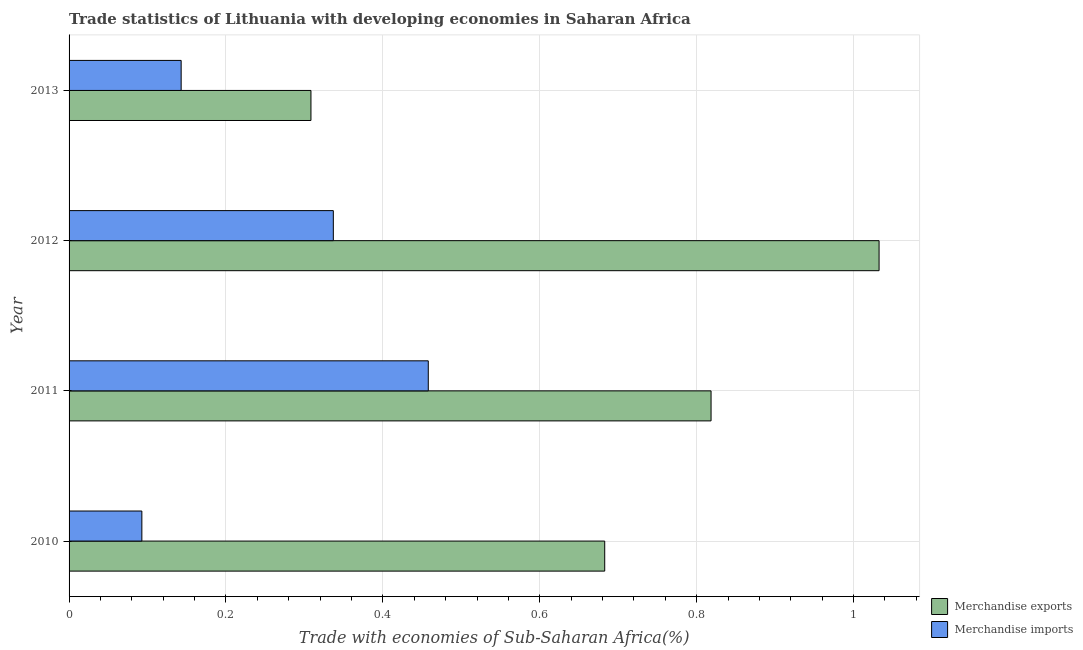Are the number of bars per tick equal to the number of legend labels?
Your response must be concise. Yes. Are the number of bars on each tick of the Y-axis equal?
Your answer should be compact. Yes. In how many cases, is the number of bars for a given year not equal to the number of legend labels?
Offer a terse response. 0. What is the merchandise imports in 2011?
Ensure brevity in your answer.  0.46. Across all years, what is the maximum merchandise imports?
Offer a terse response. 0.46. Across all years, what is the minimum merchandise exports?
Offer a very short reply. 0.31. In which year was the merchandise exports maximum?
Offer a very short reply. 2012. In which year was the merchandise exports minimum?
Make the answer very short. 2013. What is the total merchandise imports in the graph?
Keep it short and to the point. 1.03. What is the difference between the merchandise exports in 2010 and that in 2013?
Keep it short and to the point. 0.37. What is the difference between the merchandise imports in 2013 and the merchandise exports in 2012?
Provide a succinct answer. -0.89. What is the average merchandise imports per year?
Keep it short and to the point. 0.26. In the year 2011, what is the difference between the merchandise exports and merchandise imports?
Your answer should be compact. 0.36. What is the ratio of the merchandise imports in 2011 to that in 2013?
Your answer should be very brief. 3.21. Is the merchandise exports in 2011 less than that in 2013?
Provide a short and direct response. No. Is the difference between the merchandise exports in 2011 and 2013 greater than the difference between the merchandise imports in 2011 and 2013?
Provide a short and direct response. Yes. What is the difference between the highest and the second highest merchandise exports?
Give a very brief answer. 0.21. What is the difference between the highest and the lowest merchandise imports?
Offer a terse response. 0.37. How many bars are there?
Your answer should be very brief. 8. Are all the bars in the graph horizontal?
Keep it short and to the point. Yes. How many years are there in the graph?
Your answer should be very brief. 4. Are the values on the major ticks of X-axis written in scientific E-notation?
Provide a short and direct response. No. Does the graph contain any zero values?
Your answer should be very brief. No. Where does the legend appear in the graph?
Keep it short and to the point. Bottom right. How are the legend labels stacked?
Your answer should be very brief. Vertical. What is the title of the graph?
Provide a short and direct response. Trade statistics of Lithuania with developing economies in Saharan Africa. Does "UN agencies" appear as one of the legend labels in the graph?
Offer a very short reply. No. What is the label or title of the X-axis?
Provide a succinct answer. Trade with economies of Sub-Saharan Africa(%). What is the label or title of the Y-axis?
Your response must be concise. Year. What is the Trade with economies of Sub-Saharan Africa(%) of Merchandise exports in 2010?
Offer a terse response. 0.68. What is the Trade with economies of Sub-Saharan Africa(%) of Merchandise imports in 2010?
Your response must be concise. 0.09. What is the Trade with economies of Sub-Saharan Africa(%) of Merchandise exports in 2011?
Your answer should be very brief. 0.82. What is the Trade with economies of Sub-Saharan Africa(%) of Merchandise imports in 2011?
Your response must be concise. 0.46. What is the Trade with economies of Sub-Saharan Africa(%) of Merchandise exports in 2012?
Offer a terse response. 1.03. What is the Trade with economies of Sub-Saharan Africa(%) of Merchandise imports in 2012?
Your response must be concise. 0.34. What is the Trade with economies of Sub-Saharan Africa(%) in Merchandise exports in 2013?
Your response must be concise. 0.31. What is the Trade with economies of Sub-Saharan Africa(%) in Merchandise imports in 2013?
Your answer should be compact. 0.14. Across all years, what is the maximum Trade with economies of Sub-Saharan Africa(%) of Merchandise exports?
Give a very brief answer. 1.03. Across all years, what is the maximum Trade with economies of Sub-Saharan Africa(%) in Merchandise imports?
Your answer should be compact. 0.46. Across all years, what is the minimum Trade with economies of Sub-Saharan Africa(%) of Merchandise exports?
Your answer should be compact. 0.31. Across all years, what is the minimum Trade with economies of Sub-Saharan Africa(%) of Merchandise imports?
Provide a short and direct response. 0.09. What is the total Trade with economies of Sub-Saharan Africa(%) of Merchandise exports in the graph?
Provide a short and direct response. 2.84. What is the total Trade with economies of Sub-Saharan Africa(%) of Merchandise imports in the graph?
Offer a terse response. 1.03. What is the difference between the Trade with economies of Sub-Saharan Africa(%) of Merchandise exports in 2010 and that in 2011?
Offer a terse response. -0.14. What is the difference between the Trade with economies of Sub-Saharan Africa(%) in Merchandise imports in 2010 and that in 2011?
Provide a short and direct response. -0.37. What is the difference between the Trade with economies of Sub-Saharan Africa(%) in Merchandise exports in 2010 and that in 2012?
Provide a succinct answer. -0.35. What is the difference between the Trade with economies of Sub-Saharan Africa(%) of Merchandise imports in 2010 and that in 2012?
Provide a short and direct response. -0.24. What is the difference between the Trade with economies of Sub-Saharan Africa(%) in Merchandise exports in 2010 and that in 2013?
Provide a short and direct response. 0.37. What is the difference between the Trade with economies of Sub-Saharan Africa(%) in Merchandise imports in 2010 and that in 2013?
Keep it short and to the point. -0.05. What is the difference between the Trade with economies of Sub-Saharan Africa(%) of Merchandise exports in 2011 and that in 2012?
Give a very brief answer. -0.21. What is the difference between the Trade with economies of Sub-Saharan Africa(%) of Merchandise imports in 2011 and that in 2012?
Your answer should be compact. 0.12. What is the difference between the Trade with economies of Sub-Saharan Africa(%) in Merchandise exports in 2011 and that in 2013?
Make the answer very short. 0.51. What is the difference between the Trade with economies of Sub-Saharan Africa(%) of Merchandise imports in 2011 and that in 2013?
Keep it short and to the point. 0.32. What is the difference between the Trade with economies of Sub-Saharan Africa(%) of Merchandise exports in 2012 and that in 2013?
Provide a short and direct response. 0.72. What is the difference between the Trade with economies of Sub-Saharan Africa(%) in Merchandise imports in 2012 and that in 2013?
Your answer should be very brief. 0.19. What is the difference between the Trade with economies of Sub-Saharan Africa(%) of Merchandise exports in 2010 and the Trade with economies of Sub-Saharan Africa(%) of Merchandise imports in 2011?
Keep it short and to the point. 0.22. What is the difference between the Trade with economies of Sub-Saharan Africa(%) of Merchandise exports in 2010 and the Trade with economies of Sub-Saharan Africa(%) of Merchandise imports in 2012?
Keep it short and to the point. 0.35. What is the difference between the Trade with economies of Sub-Saharan Africa(%) in Merchandise exports in 2010 and the Trade with economies of Sub-Saharan Africa(%) in Merchandise imports in 2013?
Provide a short and direct response. 0.54. What is the difference between the Trade with economies of Sub-Saharan Africa(%) of Merchandise exports in 2011 and the Trade with economies of Sub-Saharan Africa(%) of Merchandise imports in 2012?
Provide a short and direct response. 0.48. What is the difference between the Trade with economies of Sub-Saharan Africa(%) in Merchandise exports in 2011 and the Trade with economies of Sub-Saharan Africa(%) in Merchandise imports in 2013?
Offer a very short reply. 0.68. What is the difference between the Trade with economies of Sub-Saharan Africa(%) of Merchandise exports in 2012 and the Trade with economies of Sub-Saharan Africa(%) of Merchandise imports in 2013?
Offer a terse response. 0.89. What is the average Trade with economies of Sub-Saharan Africa(%) of Merchandise exports per year?
Offer a terse response. 0.71. What is the average Trade with economies of Sub-Saharan Africa(%) in Merchandise imports per year?
Your answer should be very brief. 0.26. In the year 2010, what is the difference between the Trade with economies of Sub-Saharan Africa(%) of Merchandise exports and Trade with economies of Sub-Saharan Africa(%) of Merchandise imports?
Keep it short and to the point. 0.59. In the year 2011, what is the difference between the Trade with economies of Sub-Saharan Africa(%) in Merchandise exports and Trade with economies of Sub-Saharan Africa(%) in Merchandise imports?
Make the answer very short. 0.36. In the year 2012, what is the difference between the Trade with economies of Sub-Saharan Africa(%) in Merchandise exports and Trade with economies of Sub-Saharan Africa(%) in Merchandise imports?
Provide a succinct answer. 0.7. In the year 2013, what is the difference between the Trade with economies of Sub-Saharan Africa(%) in Merchandise exports and Trade with economies of Sub-Saharan Africa(%) in Merchandise imports?
Make the answer very short. 0.17. What is the ratio of the Trade with economies of Sub-Saharan Africa(%) in Merchandise exports in 2010 to that in 2011?
Your answer should be compact. 0.83. What is the ratio of the Trade with economies of Sub-Saharan Africa(%) in Merchandise imports in 2010 to that in 2011?
Keep it short and to the point. 0.2. What is the ratio of the Trade with economies of Sub-Saharan Africa(%) in Merchandise exports in 2010 to that in 2012?
Your response must be concise. 0.66. What is the ratio of the Trade with economies of Sub-Saharan Africa(%) of Merchandise imports in 2010 to that in 2012?
Ensure brevity in your answer.  0.28. What is the ratio of the Trade with economies of Sub-Saharan Africa(%) in Merchandise exports in 2010 to that in 2013?
Your answer should be compact. 2.21. What is the ratio of the Trade with economies of Sub-Saharan Africa(%) of Merchandise imports in 2010 to that in 2013?
Your response must be concise. 0.65. What is the ratio of the Trade with economies of Sub-Saharan Africa(%) of Merchandise exports in 2011 to that in 2012?
Offer a very short reply. 0.79. What is the ratio of the Trade with economies of Sub-Saharan Africa(%) of Merchandise imports in 2011 to that in 2012?
Provide a succinct answer. 1.36. What is the ratio of the Trade with economies of Sub-Saharan Africa(%) in Merchandise exports in 2011 to that in 2013?
Your answer should be very brief. 2.65. What is the ratio of the Trade with economies of Sub-Saharan Africa(%) in Merchandise imports in 2011 to that in 2013?
Give a very brief answer. 3.2. What is the ratio of the Trade with economies of Sub-Saharan Africa(%) of Merchandise exports in 2012 to that in 2013?
Ensure brevity in your answer.  3.35. What is the ratio of the Trade with economies of Sub-Saharan Africa(%) in Merchandise imports in 2012 to that in 2013?
Offer a very short reply. 2.36. What is the difference between the highest and the second highest Trade with economies of Sub-Saharan Africa(%) of Merchandise exports?
Make the answer very short. 0.21. What is the difference between the highest and the second highest Trade with economies of Sub-Saharan Africa(%) in Merchandise imports?
Ensure brevity in your answer.  0.12. What is the difference between the highest and the lowest Trade with economies of Sub-Saharan Africa(%) in Merchandise exports?
Offer a terse response. 0.72. What is the difference between the highest and the lowest Trade with economies of Sub-Saharan Africa(%) of Merchandise imports?
Make the answer very short. 0.37. 